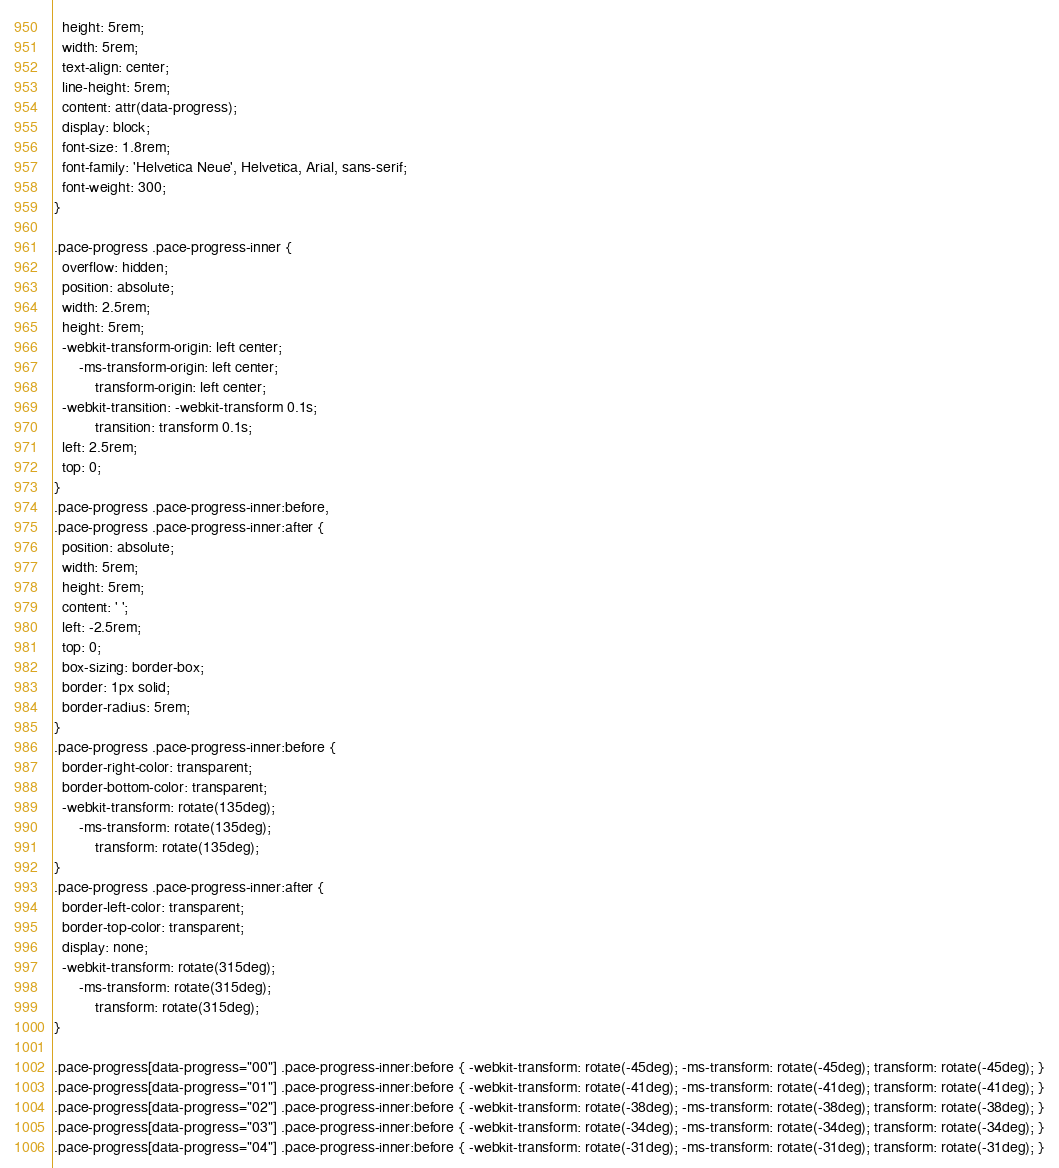<code> <loc_0><loc_0><loc_500><loc_500><_CSS_>  height: 5rem;
  width: 5rem;
  text-align: center;
  line-height: 5rem;
  content: attr(data-progress);
  display: block;
  font-size: 1.8rem;
  font-family: 'Helvetica Neue', Helvetica, Arial, sans-serif;
  font-weight: 300;
}

.pace-progress .pace-progress-inner {
  overflow: hidden;
  position: absolute;
  width: 2.5rem;
  height: 5rem;
  -webkit-transform-origin: left center;
      -ms-transform-origin: left center;
          transform-origin: left center;
  -webkit-transition: -webkit-transform 0.1s;
          transition: transform 0.1s;
  left: 2.5rem;
  top: 0;
}
.pace-progress .pace-progress-inner:before,
.pace-progress .pace-progress-inner:after {
  position: absolute;
  width: 5rem;
  height: 5rem;
  content: ' ';
  left: -2.5rem;
  top: 0;
  box-sizing: border-box;
  border: 1px solid;
  border-radius: 5rem;
}
.pace-progress .pace-progress-inner:before {
  border-right-color: transparent;
  border-bottom-color: transparent;
  -webkit-transform: rotate(135deg);
      -ms-transform: rotate(135deg);
          transform: rotate(135deg);
}
.pace-progress .pace-progress-inner:after {
  border-left-color: transparent;
  border-top-color: transparent;
  display: none;
  -webkit-transform: rotate(315deg);
      -ms-transform: rotate(315deg);
          transform: rotate(315deg);
}

.pace-progress[data-progress="00"] .pace-progress-inner:before { -webkit-transform: rotate(-45deg); -ms-transform: rotate(-45deg); transform: rotate(-45deg); }
.pace-progress[data-progress="01"] .pace-progress-inner:before { -webkit-transform: rotate(-41deg); -ms-transform: rotate(-41deg); transform: rotate(-41deg); }
.pace-progress[data-progress="02"] .pace-progress-inner:before { -webkit-transform: rotate(-38deg); -ms-transform: rotate(-38deg); transform: rotate(-38deg); }
.pace-progress[data-progress="03"] .pace-progress-inner:before { -webkit-transform: rotate(-34deg); -ms-transform: rotate(-34deg); transform: rotate(-34deg); }
.pace-progress[data-progress="04"] .pace-progress-inner:before { -webkit-transform: rotate(-31deg); -ms-transform: rotate(-31deg); transform: rotate(-31deg); }</code> 